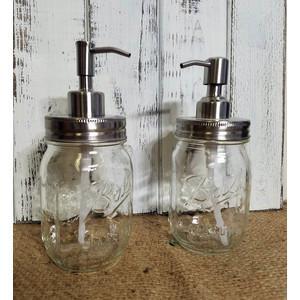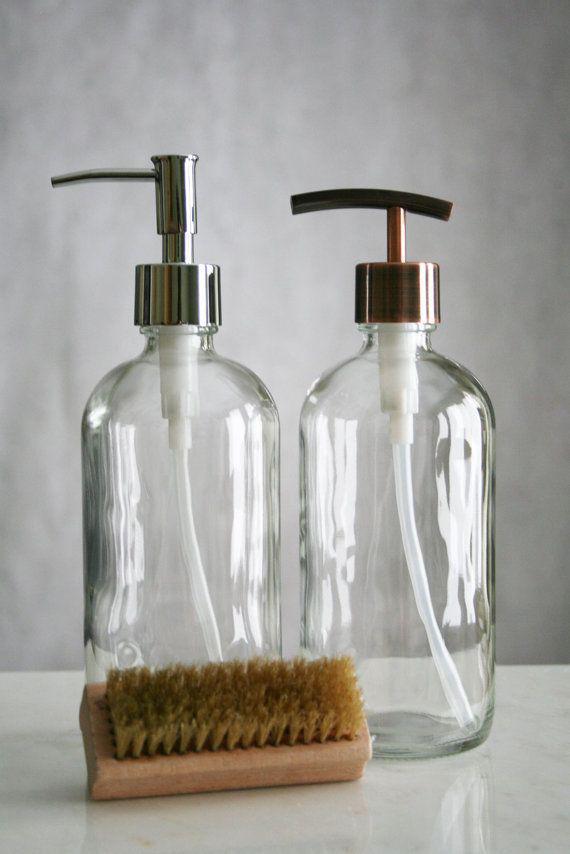The first image is the image on the left, the second image is the image on the right. Evaluate the accuracy of this statement regarding the images: "An image shows a pair of pump-top dispensers in a wire caddy with an oval medallion on the front, and the other image includes a jar of toothbrushes.". Is it true? Answer yes or no. No. The first image is the image on the left, the second image is the image on the right. Analyze the images presented: Is the assertion "The left image contains exactly two glass jar dispensers." valid? Answer yes or no. Yes. 